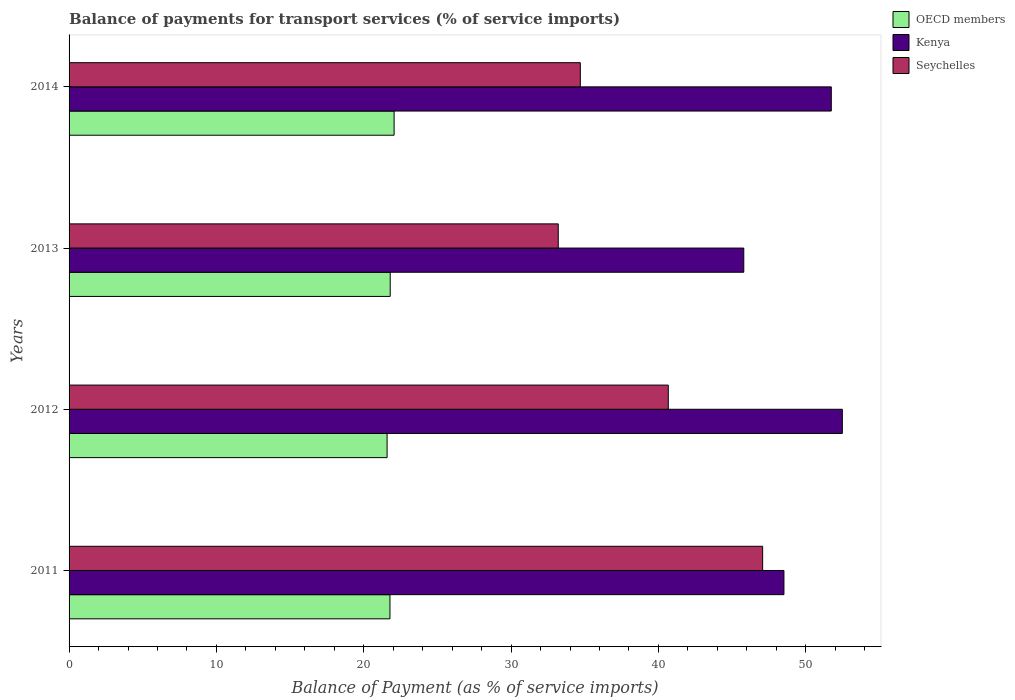Are the number of bars per tick equal to the number of legend labels?
Offer a terse response. Yes. Are the number of bars on each tick of the Y-axis equal?
Keep it short and to the point. Yes. How many bars are there on the 4th tick from the top?
Give a very brief answer. 3. What is the label of the 1st group of bars from the top?
Offer a terse response. 2014. What is the balance of payments for transport services in Kenya in 2011?
Offer a very short reply. 48.52. Across all years, what is the maximum balance of payments for transport services in Seychelles?
Give a very brief answer. 47.08. Across all years, what is the minimum balance of payments for transport services in Seychelles?
Give a very brief answer. 33.2. In which year was the balance of payments for transport services in Kenya minimum?
Your answer should be very brief. 2013. What is the total balance of payments for transport services in Seychelles in the graph?
Provide a short and direct response. 155.65. What is the difference between the balance of payments for transport services in Seychelles in 2012 and that in 2013?
Offer a very short reply. 7.47. What is the difference between the balance of payments for transport services in OECD members in 2011 and the balance of payments for transport services in Seychelles in 2013?
Ensure brevity in your answer.  -11.42. What is the average balance of payments for transport services in Kenya per year?
Offer a terse response. 49.63. In the year 2012, what is the difference between the balance of payments for transport services in OECD members and balance of payments for transport services in Seychelles?
Ensure brevity in your answer.  -19.08. In how many years, is the balance of payments for transport services in OECD members greater than 14 %?
Offer a terse response. 4. What is the ratio of the balance of payments for transport services in Seychelles in 2012 to that in 2013?
Ensure brevity in your answer.  1.22. Is the balance of payments for transport services in Seychelles in 2012 less than that in 2014?
Offer a terse response. No. Is the difference between the balance of payments for transport services in OECD members in 2012 and 2013 greater than the difference between the balance of payments for transport services in Seychelles in 2012 and 2013?
Give a very brief answer. No. What is the difference between the highest and the second highest balance of payments for transport services in Seychelles?
Offer a very short reply. 6.41. What is the difference between the highest and the lowest balance of payments for transport services in Kenya?
Ensure brevity in your answer.  6.69. Is the sum of the balance of payments for transport services in Seychelles in 2012 and 2014 greater than the maximum balance of payments for transport services in Kenya across all years?
Offer a very short reply. Yes. What does the 3rd bar from the top in 2011 represents?
Ensure brevity in your answer.  OECD members. What does the 3rd bar from the bottom in 2013 represents?
Give a very brief answer. Seychelles. Is it the case that in every year, the sum of the balance of payments for transport services in Kenya and balance of payments for transport services in OECD members is greater than the balance of payments for transport services in Seychelles?
Keep it short and to the point. Yes. Are all the bars in the graph horizontal?
Your answer should be very brief. Yes. How many years are there in the graph?
Give a very brief answer. 4. Does the graph contain grids?
Provide a succinct answer. No. Where does the legend appear in the graph?
Your answer should be very brief. Top right. How are the legend labels stacked?
Provide a short and direct response. Vertical. What is the title of the graph?
Keep it short and to the point. Balance of payments for transport services (% of service imports). What is the label or title of the X-axis?
Offer a terse response. Balance of Payment (as % of service imports). What is the Balance of Payment (as % of service imports) of OECD members in 2011?
Ensure brevity in your answer.  21.78. What is the Balance of Payment (as % of service imports) in Kenya in 2011?
Ensure brevity in your answer.  48.52. What is the Balance of Payment (as % of service imports) of Seychelles in 2011?
Give a very brief answer. 47.08. What is the Balance of Payment (as % of service imports) in OECD members in 2012?
Provide a succinct answer. 21.59. What is the Balance of Payment (as % of service imports) of Kenya in 2012?
Ensure brevity in your answer.  52.48. What is the Balance of Payment (as % of service imports) in Seychelles in 2012?
Give a very brief answer. 40.67. What is the Balance of Payment (as % of service imports) in OECD members in 2013?
Provide a short and direct response. 21.8. What is the Balance of Payment (as % of service imports) of Kenya in 2013?
Give a very brief answer. 45.8. What is the Balance of Payment (as % of service imports) in Seychelles in 2013?
Give a very brief answer. 33.2. What is the Balance of Payment (as % of service imports) in OECD members in 2014?
Your answer should be very brief. 22.06. What is the Balance of Payment (as % of service imports) in Kenya in 2014?
Give a very brief answer. 51.74. What is the Balance of Payment (as % of service imports) in Seychelles in 2014?
Make the answer very short. 34.7. Across all years, what is the maximum Balance of Payment (as % of service imports) in OECD members?
Give a very brief answer. 22.06. Across all years, what is the maximum Balance of Payment (as % of service imports) of Kenya?
Your answer should be very brief. 52.48. Across all years, what is the maximum Balance of Payment (as % of service imports) in Seychelles?
Offer a terse response. 47.08. Across all years, what is the minimum Balance of Payment (as % of service imports) of OECD members?
Provide a short and direct response. 21.59. Across all years, what is the minimum Balance of Payment (as % of service imports) in Kenya?
Offer a very short reply. 45.8. Across all years, what is the minimum Balance of Payment (as % of service imports) in Seychelles?
Provide a short and direct response. 33.2. What is the total Balance of Payment (as % of service imports) in OECD members in the graph?
Your answer should be very brief. 87.22. What is the total Balance of Payment (as % of service imports) of Kenya in the graph?
Your answer should be very brief. 198.54. What is the total Balance of Payment (as % of service imports) in Seychelles in the graph?
Give a very brief answer. 155.65. What is the difference between the Balance of Payment (as % of service imports) of OECD members in 2011 and that in 2012?
Your answer should be compact. 0.19. What is the difference between the Balance of Payment (as % of service imports) in Kenya in 2011 and that in 2012?
Offer a terse response. -3.96. What is the difference between the Balance of Payment (as % of service imports) of Seychelles in 2011 and that in 2012?
Your response must be concise. 6.41. What is the difference between the Balance of Payment (as % of service imports) in OECD members in 2011 and that in 2013?
Give a very brief answer. -0.02. What is the difference between the Balance of Payment (as % of service imports) of Kenya in 2011 and that in 2013?
Offer a terse response. 2.73. What is the difference between the Balance of Payment (as % of service imports) of Seychelles in 2011 and that in 2013?
Give a very brief answer. 13.87. What is the difference between the Balance of Payment (as % of service imports) in OECD members in 2011 and that in 2014?
Provide a succinct answer. -0.28. What is the difference between the Balance of Payment (as % of service imports) of Kenya in 2011 and that in 2014?
Ensure brevity in your answer.  -3.21. What is the difference between the Balance of Payment (as % of service imports) in Seychelles in 2011 and that in 2014?
Offer a terse response. 12.38. What is the difference between the Balance of Payment (as % of service imports) of OECD members in 2012 and that in 2013?
Your answer should be very brief. -0.21. What is the difference between the Balance of Payment (as % of service imports) in Kenya in 2012 and that in 2013?
Keep it short and to the point. 6.69. What is the difference between the Balance of Payment (as % of service imports) of Seychelles in 2012 and that in 2013?
Provide a short and direct response. 7.47. What is the difference between the Balance of Payment (as % of service imports) in OECD members in 2012 and that in 2014?
Your answer should be compact. -0.48. What is the difference between the Balance of Payment (as % of service imports) in Kenya in 2012 and that in 2014?
Your answer should be very brief. 0.75. What is the difference between the Balance of Payment (as % of service imports) in Seychelles in 2012 and that in 2014?
Ensure brevity in your answer.  5.97. What is the difference between the Balance of Payment (as % of service imports) of OECD members in 2013 and that in 2014?
Offer a very short reply. -0.26. What is the difference between the Balance of Payment (as % of service imports) in Kenya in 2013 and that in 2014?
Ensure brevity in your answer.  -5.94. What is the difference between the Balance of Payment (as % of service imports) in Seychelles in 2013 and that in 2014?
Provide a succinct answer. -1.5. What is the difference between the Balance of Payment (as % of service imports) in OECD members in 2011 and the Balance of Payment (as % of service imports) in Kenya in 2012?
Provide a short and direct response. -30.7. What is the difference between the Balance of Payment (as % of service imports) of OECD members in 2011 and the Balance of Payment (as % of service imports) of Seychelles in 2012?
Your answer should be compact. -18.89. What is the difference between the Balance of Payment (as % of service imports) of Kenya in 2011 and the Balance of Payment (as % of service imports) of Seychelles in 2012?
Make the answer very short. 7.85. What is the difference between the Balance of Payment (as % of service imports) of OECD members in 2011 and the Balance of Payment (as % of service imports) of Kenya in 2013?
Offer a terse response. -24.02. What is the difference between the Balance of Payment (as % of service imports) in OECD members in 2011 and the Balance of Payment (as % of service imports) in Seychelles in 2013?
Your answer should be very brief. -11.42. What is the difference between the Balance of Payment (as % of service imports) in Kenya in 2011 and the Balance of Payment (as % of service imports) in Seychelles in 2013?
Your answer should be very brief. 15.32. What is the difference between the Balance of Payment (as % of service imports) in OECD members in 2011 and the Balance of Payment (as % of service imports) in Kenya in 2014?
Provide a short and direct response. -29.96. What is the difference between the Balance of Payment (as % of service imports) in OECD members in 2011 and the Balance of Payment (as % of service imports) in Seychelles in 2014?
Offer a terse response. -12.92. What is the difference between the Balance of Payment (as % of service imports) of Kenya in 2011 and the Balance of Payment (as % of service imports) of Seychelles in 2014?
Offer a terse response. 13.82. What is the difference between the Balance of Payment (as % of service imports) of OECD members in 2012 and the Balance of Payment (as % of service imports) of Kenya in 2013?
Offer a terse response. -24.21. What is the difference between the Balance of Payment (as % of service imports) of OECD members in 2012 and the Balance of Payment (as % of service imports) of Seychelles in 2013?
Ensure brevity in your answer.  -11.62. What is the difference between the Balance of Payment (as % of service imports) of Kenya in 2012 and the Balance of Payment (as % of service imports) of Seychelles in 2013?
Your answer should be very brief. 19.28. What is the difference between the Balance of Payment (as % of service imports) in OECD members in 2012 and the Balance of Payment (as % of service imports) in Kenya in 2014?
Provide a succinct answer. -30.15. What is the difference between the Balance of Payment (as % of service imports) of OECD members in 2012 and the Balance of Payment (as % of service imports) of Seychelles in 2014?
Make the answer very short. -13.11. What is the difference between the Balance of Payment (as % of service imports) in Kenya in 2012 and the Balance of Payment (as % of service imports) in Seychelles in 2014?
Your answer should be very brief. 17.78. What is the difference between the Balance of Payment (as % of service imports) of OECD members in 2013 and the Balance of Payment (as % of service imports) of Kenya in 2014?
Keep it short and to the point. -29.94. What is the difference between the Balance of Payment (as % of service imports) of OECD members in 2013 and the Balance of Payment (as % of service imports) of Seychelles in 2014?
Offer a very short reply. -12.9. What is the difference between the Balance of Payment (as % of service imports) in Kenya in 2013 and the Balance of Payment (as % of service imports) in Seychelles in 2014?
Offer a very short reply. 11.1. What is the average Balance of Payment (as % of service imports) in OECD members per year?
Offer a terse response. 21.81. What is the average Balance of Payment (as % of service imports) in Kenya per year?
Offer a very short reply. 49.63. What is the average Balance of Payment (as % of service imports) of Seychelles per year?
Give a very brief answer. 38.91. In the year 2011, what is the difference between the Balance of Payment (as % of service imports) of OECD members and Balance of Payment (as % of service imports) of Kenya?
Provide a succinct answer. -26.74. In the year 2011, what is the difference between the Balance of Payment (as % of service imports) of OECD members and Balance of Payment (as % of service imports) of Seychelles?
Make the answer very short. -25.3. In the year 2011, what is the difference between the Balance of Payment (as % of service imports) in Kenya and Balance of Payment (as % of service imports) in Seychelles?
Offer a terse response. 1.45. In the year 2012, what is the difference between the Balance of Payment (as % of service imports) in OECD members and Balance of Payment (as % of service imports) in Kenya?
Make the answer very short. -30.9. In the year 2012, what is the difference between the Balance of Payment (as % of service imports) of OECD members and Balance of Payment (as % of service imports) of Seychelles?
Provide a succinct answer. -19.08. In the year 2012, what is the difference between the Balance of Payment (as % of service imports) of Kenya and Balance of Payment (as % of service imports) of Seychelles?
Provide a short and direct response. 11.81. In the year 2013, what is the difference between the Balance of Payment (as % of service imports) of OECD members and Balance of Payment (as % of service imports) of Kenya?
Provide a short and direct response. -24. In the year 2013, what is the difference between the Balance of Payment (as % of service imports) of OECD members and Balance of Payment (as % of service imports) of Seychelles?
Provide a short and direct response. -11.4. In the year 2013, what is the difference between the Balance of Payment (as % of service imports) in Kenya and Balance of Payment (as % of service imports) in Seychelles?
Keep it short and to the point. 12.59. In the year 2014, what is the difference between the Balance of Payment (as % of service imports) of OECD members and Balance of Payment (as % of service imports) of Kenya?
Offer a very short reply. -29.67. In the year 2014, what is the difference between the Balance of Payment (as % of service imports) of OECD members and Balance of Payment (as % of service imports) of Seychelles?
Your response must be concise. -12.64. In the year 2014, what is the difference between the Balance of Payment (as % of service imports) of Kenya and Balance of Payment (as % of service imports) of Seychelles?
Provide a short and direct response. 17.04. What is the ratio of the Balance of Payment (as % of service imports) in Kenya in 2011 to that in 2012?
Your answer should be very brief. 0.92. What is the ratio of the Balance of Payment (as % of service imports) of Seychelles in 2011 to that in 2012?
Ensure brevity in your answer.  1.16. What is the ratio of the Balance of Payment (as % of service imports) of OECD members in 2011 to that in 2013?
Your answer should be compact. 1. What is the ratio of the Balance of Payment (as % of service imports) in Kenya in 2011 to that in 2013?
Your answer should be very brief. 1.06. What is the ratio of the Balance of Payment (as % of service imports) of Seychelles in 2011 to that in 2013?
Provide a succinct answer. 1.42. What is the ratio of the Balance of Payment (as % of service imports) of OECD members in 2011 to that in 2014?
Provide a short and direct response. 0.99. What is the ratio of the Balance of Payment (as % of service imports) in Kenya in 2011 to that in 2014?
Give a very brief answer. 0.94. What is the ratio of the Balance of Payment (as % of service imports) of Seychelles in 2011 to that in 2014?
Offer a terse response. 1.36. What is the ratio of the Balance of Payment (as % of service imports) in OECD members in 2012 to that in 2013?
Your answer should be very brief. 0.99. What is the ratio of the Balance of Payment (as % of service imports) of Kenya in 2012 to that in 2013?
Provide a short and direct response. 1.15. What is the ratio of the Balance of Payment (as % of service imports) of Seychelles in 2012 to that in 2013?
Offer a terse response. 1.22. What is the ratio of the Balance of Payment (as % of service imports) in OECD members in 2012 to that in 2014?
Offer a terse response. 0.98. What is the ratio of the Balance of Payment (as % of service imports) of Kenya in 2012 to that in 2014?
Your answer should be compact. 1.01. What is the ratio of the Balance of Payment (as % of service imports) of Seychelles in 2012 to that in 2014?
Keep it short and to the point. 1.17. What is the ratio of the Balance of Payment (as % of service imports) in OECD members in 2013 to that in 2014?
Ensure brevity in your answer.  0.99. What is the ratio of the Balance of Payment (as % of service imports) in Kenya in 2013 to that in 2014?
Make the answer very short. 0.89. What is the ratio of the Balance of Payment (as % of service imports) of Seychelles in 2013 to that in 2014?
Keep it short and to the point. 0.96. What is the difference between the highest and the second highest Balance of Payment (as % of service imports) in OECD members?
Provide a short and direct response. 0.26. What is the difference between the highest and the second highest Balance of Payment (as % of service imports) in Kenya?
Give a very brief answer. 0.75. What is the difference between the highest and the second highest Balance of Payment (as % of service imports) in Seychelles?
Offer a terse response. 6.41. What is the difference between the highest and the lowest Balance of Payment (as % of service imports) of OECD members?
Provide a succinct answer. 0.48. What is the difference between the highest and the lowest Balance of Payment (as % of service imports) in Kenya?
Your response must be concise. 6.69. What is the difference between the highest and the lowest Balance of Payment (as % of service imports) of Seychelles?
Give a very brief answer. 13.87. 